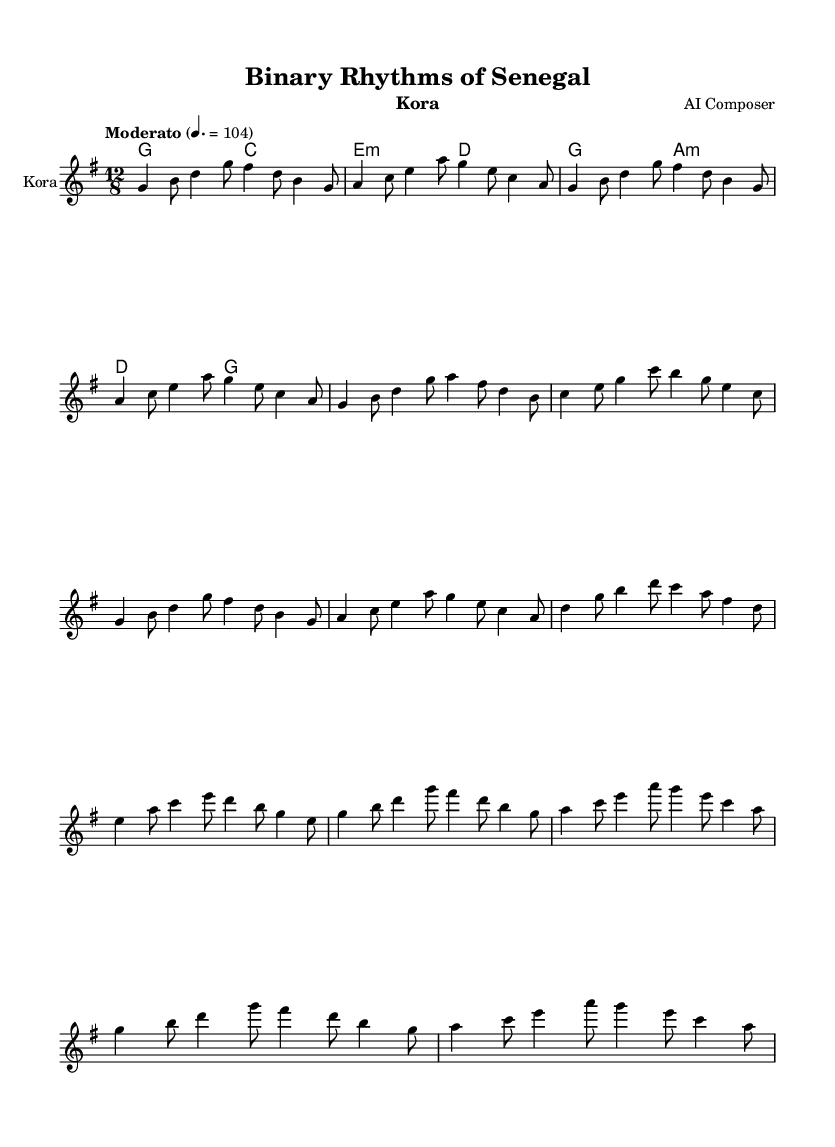What is the key signature of this music? The key signature is G major, which has one sharp (F#). This can be identified by looking at the beginning of the staff where the sharp sign is positioned.
Answer: G major What is the time signature of this music? The time signature is 12/8, indicating that there are 12 eighth notes in a measure. This is seen at the beginning of the score, where the "12/8" notation is clearly stated.
Answer: 12/8 What is the tempo marking for this piece? The tempo marking is "Moderato," indicating a medium speed. This is indicated in the score next to the tempo indication, just below the key and time signatures.
Answer: Moderato How many distinct sections are in the music? The music consists of 6 distinct sections labeled as Intro, A, B, A', C, A'', and Outro. Each section is clearly marked in the code and structure of the sheet music.
Answer: 6 What is the structure of the repeating sections? The structure includes sections A and A'' which are repeated, along with B and C being distinct. This can be traced by looking at the labels and how often A and A'' recur in the piece.
Answer: A, A'', B, C What type of instrument is this sheet music for? The instrument for this sheet music is the Kora, which is specified in the header of the score. This information is explicitly stated at the top of the sheet music under the instrument label.
Answer: Kora 